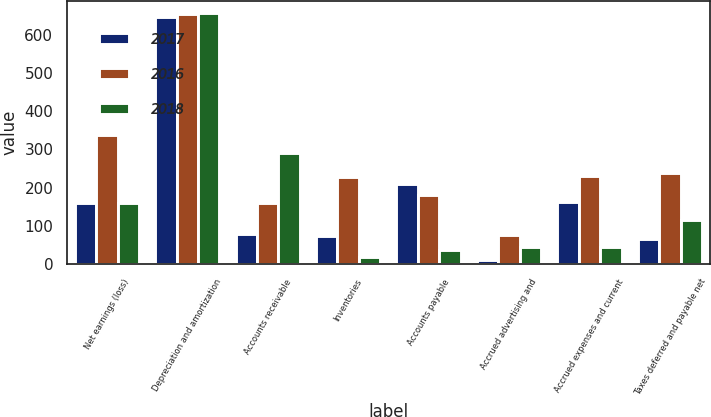Convert chart to OTSL. <chart><loc_0><loc_0><loc_500><loc_500><stacked_bar_chart><ecel><fcel>Net earnings (loss)<fcel>Depreciation and amortization<fcel>Accounts receivable<fcel>Inventories<fcel>Accounts payable<fcel>Accrued advertising and<fcel>Accrued expenses and current<fcel>Taxes deferred and payable net<nl><fcel>2017<fcel>159<fcel>645<fcel>79<fcel>73<fcel>210<fcel>12<fcel>162<fcel>67<nl><fcel>2016<fcel>337<fcel>654<fcel>160<fcel>229<fcel>180<fcel>76<fcel>230<fcel>239<nl><fcel>2018<fcel>160<fcel>655<fcel>291<fcel>18<fcel>37<fcel>46<fcel>46<fcel>116<nl></chart> 